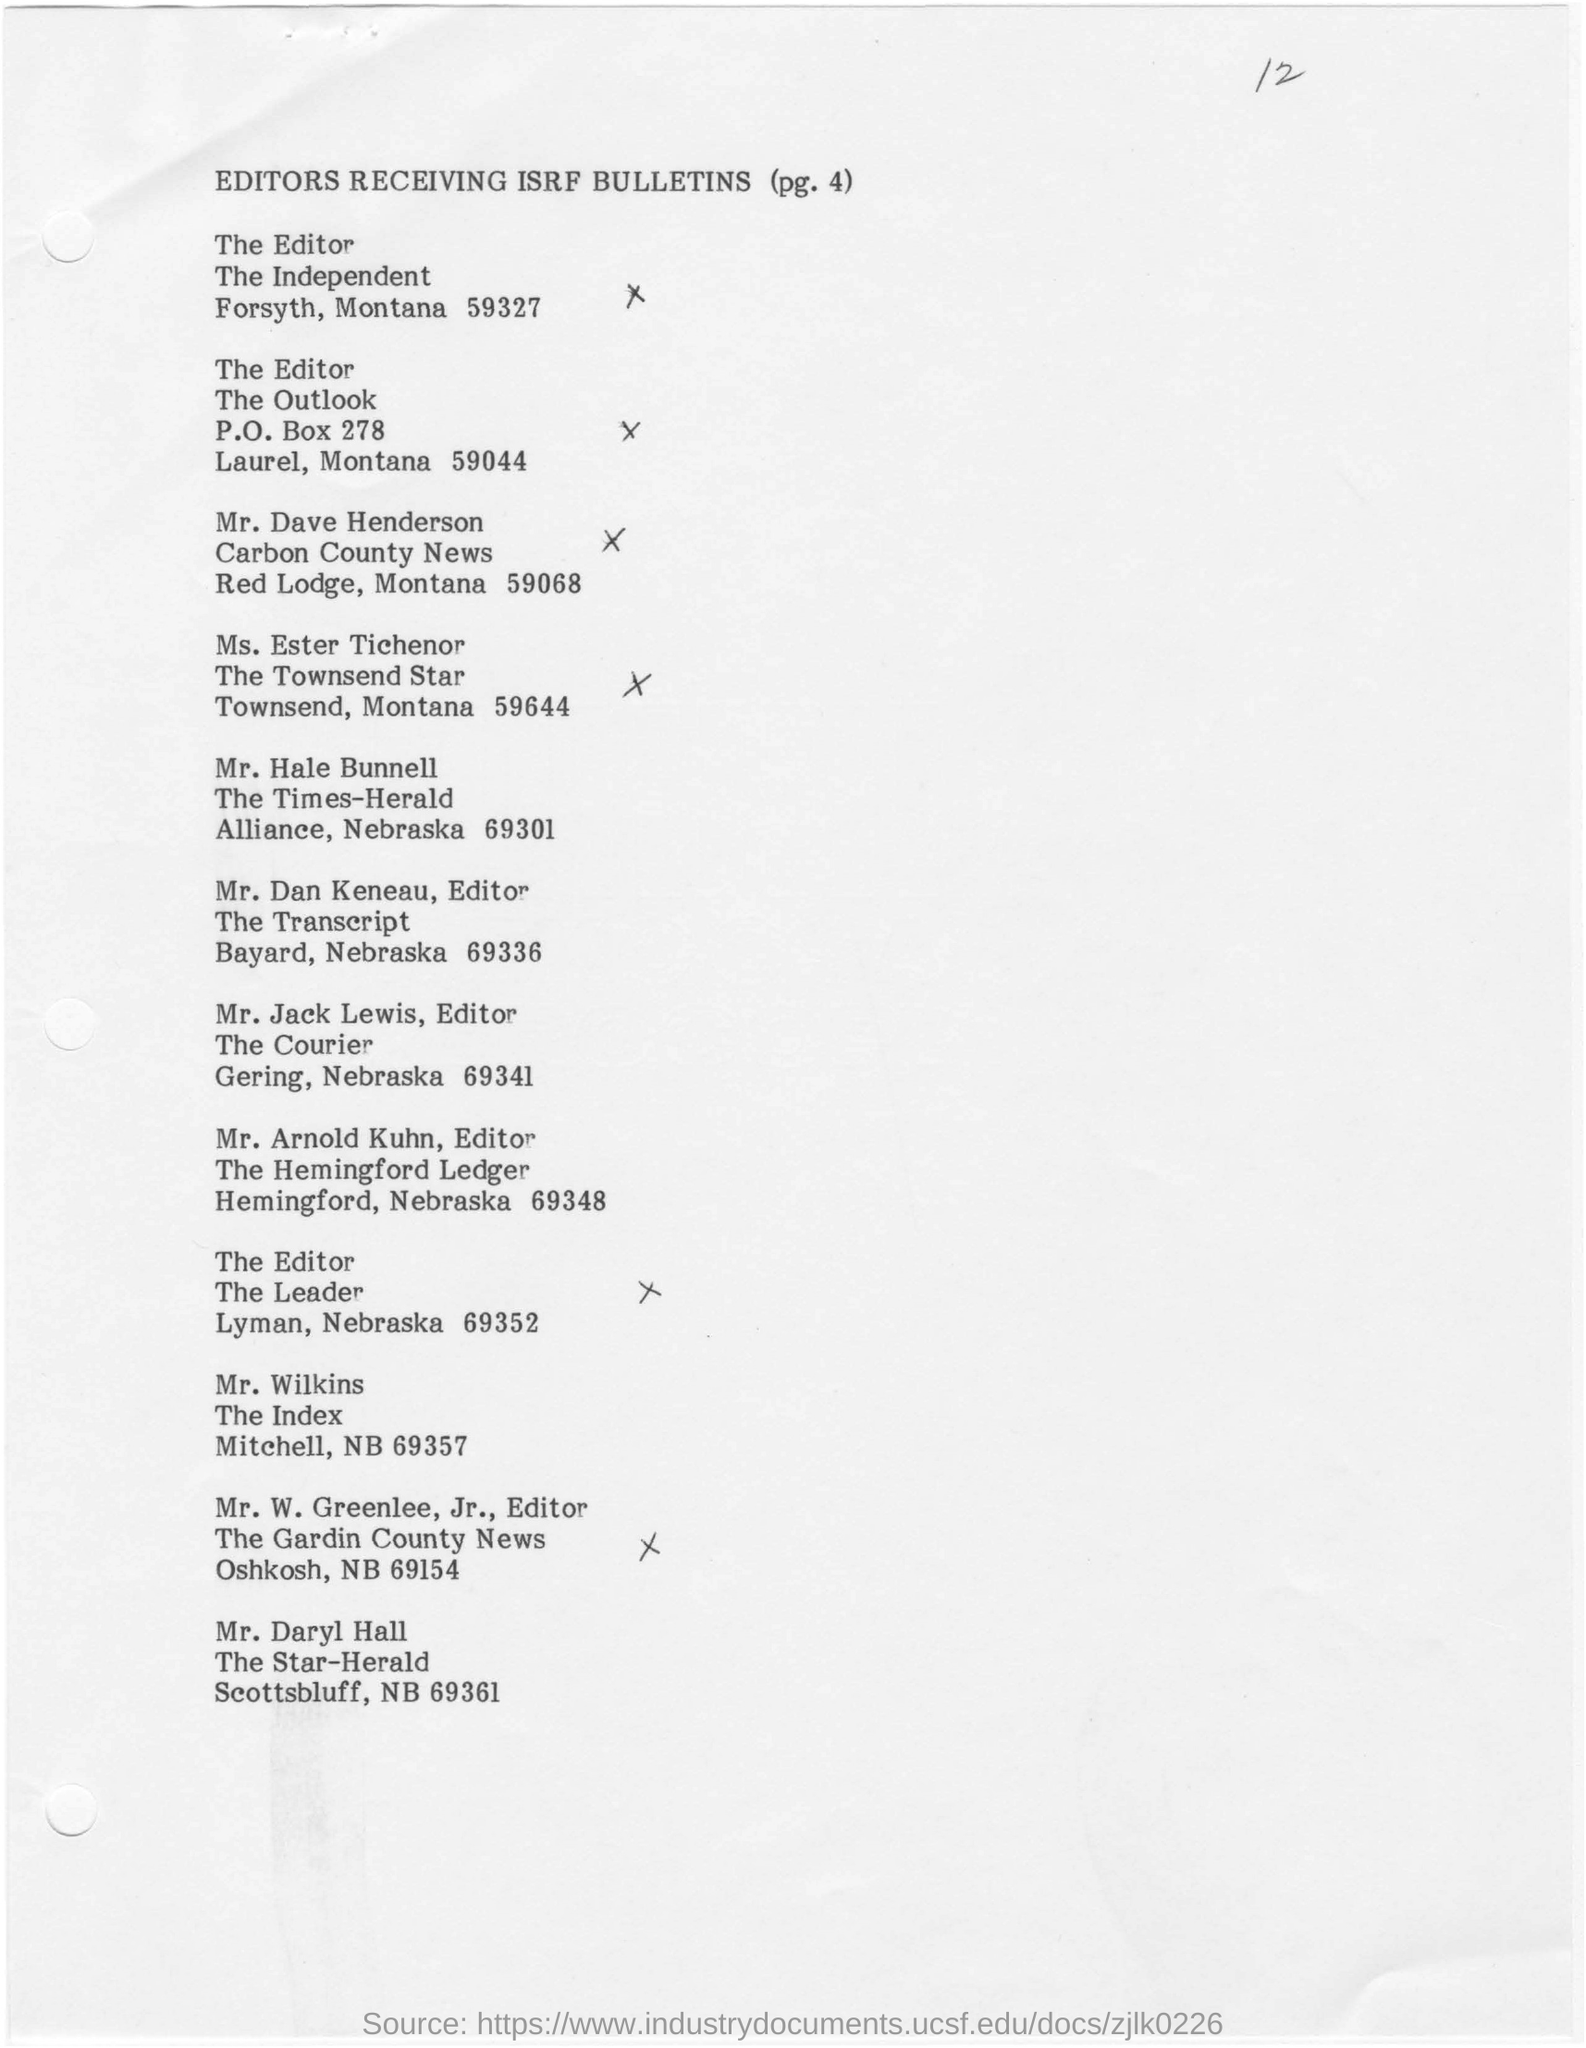What is the heading of this document?
Provide a short and direct response. Editors Receiving ISRF Bulletins. 